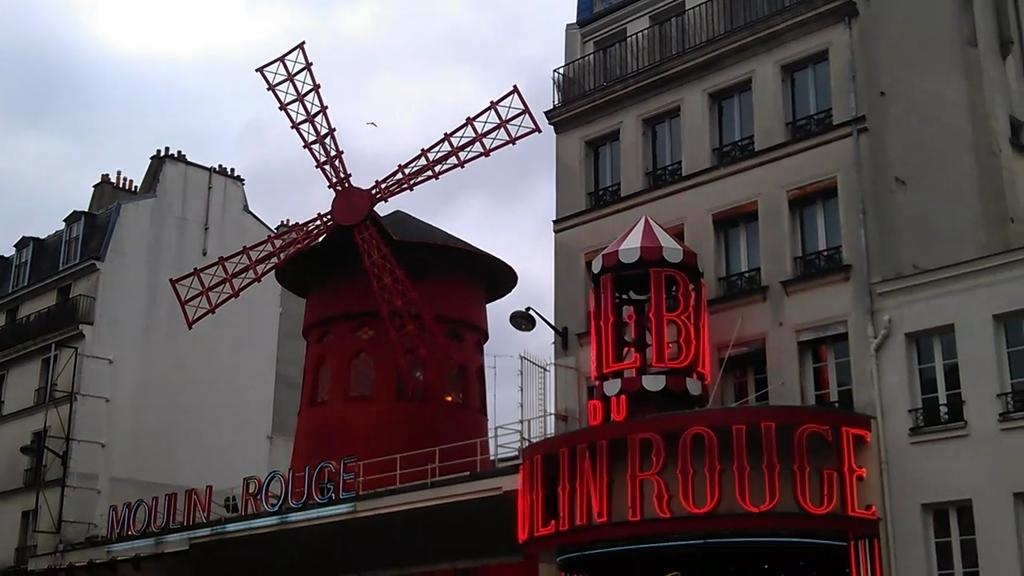What type of structures can be seen in the image? There are buildings in the image. What architectural feature is visible on the buildings? There are windows in the image. What other objects can be seen in the image? There are boards in the image. What is visible in the background of the image? The sky is visible in the background of the image. What type of zephyr can be seen blowing through the buildings in the image? There is no zephyr present in the image; it is a still image. What is the name of the person who took the image? The name of the person who took the image is not mentioned in the provided facts. How many sheep are visible in the image? There are no sheep present in the image. 